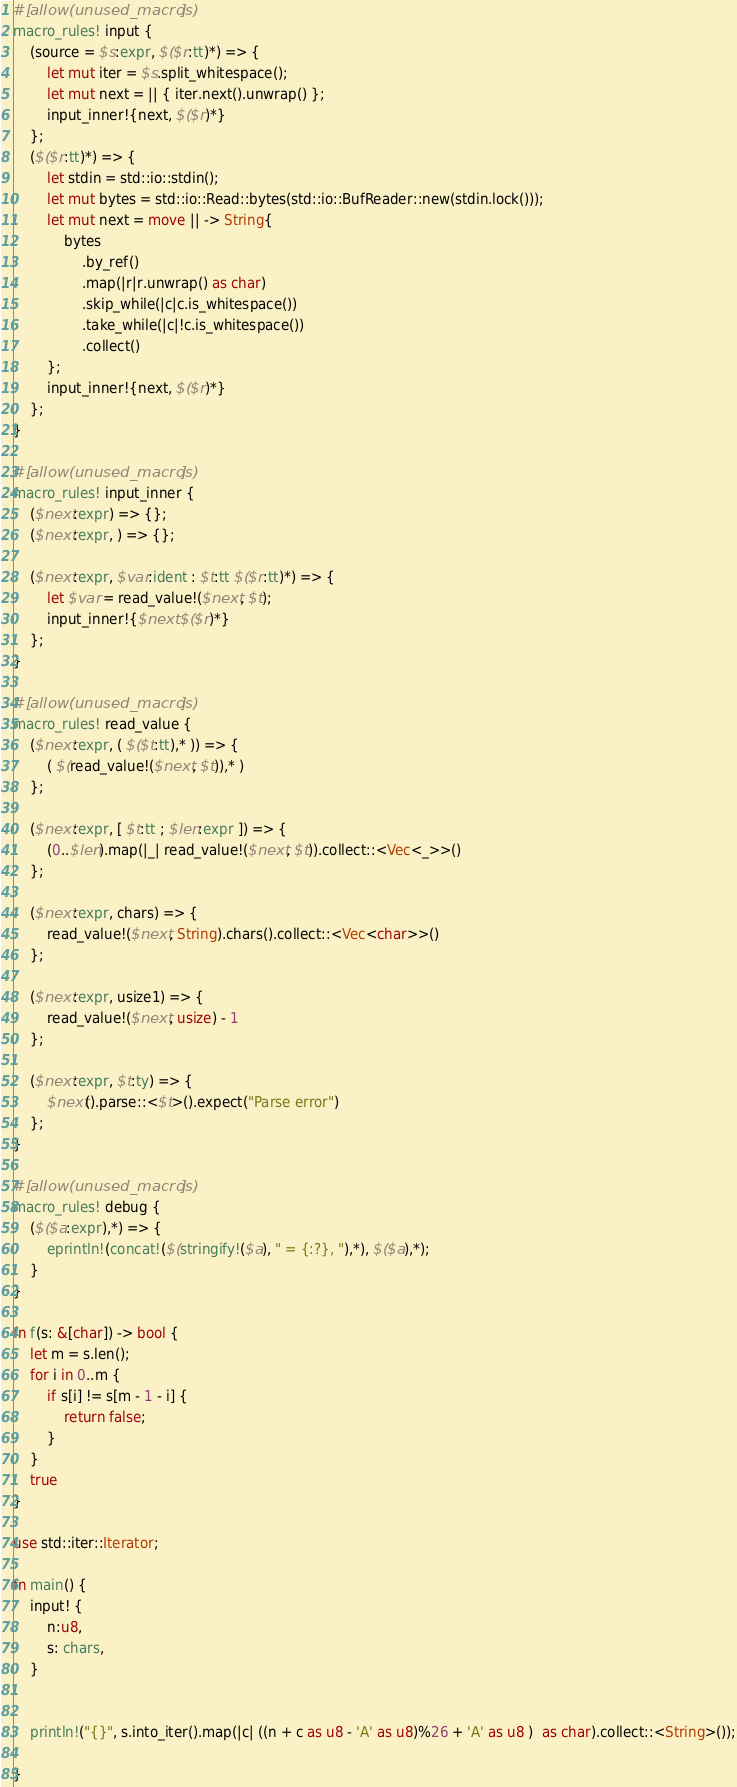<code> <loc_0><loc_0><loc_500><loc_500><_Rust_>#[allow(unused_macros)]
macro_rules! input {
    (source = $s:expr, $($r:tt)*) => {
        let mut iter = $s.split_whitespace();
        let mut next = || { iter.next().unwrap() };
        input_inner!{next, $($r)*}
    };
    ($($r:tt)*) => {
        let stdin = std::io::stdin();
        let mut bytes = std::io::Read::bytes(std::io::BufReader::new(stdin.lock()));
        let mut next = move || -> String{
            bytes
                .by_ref()
                .map(|r|r.unwrap() as char)
                .skip_while(|c|c.is_whitespace())
                .take_while(|c|!c.is_whitespace())
                .collect()
        };
        input_inner!{next, $($r)*}
    };
}

#[allow(unused_macros)]
macro_rules! input_inner {
    ($next:expr) => {};
    ($next:expr, ) => {};

    ($next:expr, $var:ident : $t:tt $($r:tt)*) => {
        let $var = read_value!($next, $t);
        input_inner!{$next $($r)*}
    };
}

#[allow(unused_macros)]
macro_rules! read_value {
    ($next:expr, ( $($t:tt),* )) => {
        ( $(read_value!($next, $t)),* )
    };

    ($next:expr, [ $t:tt ; $len:expr ]) => {
        (0..$len).map(|_| read_value!($next, $t)).collect::<Vec<_>>()
    };

    ($next:expr, chars) => {
        read_value!($next, String).chars().collect::<Vec<char>>()
    };

    ($next:expr, usize1) => {
        read_value!($next, usize) - 1
    };

    ($next:expr, $t:ty) => {
        $next().parse::<$t>().expect("Parse error")
    };
}

#[allow(unused_macros)]
macro_rules! debug {
    ($($a:expr),*) => {
        eprintln!(concat!($(stringify!($a), " = {:?}, "),*), $($a),*);
    }
}

fn f(s: &[char]) -> bool {
    let m = s.len();
    for i in 0..m {
        if s[i] != s[m - 1 - i] {
            return false;
        }
    }
    true
}

use std::iter::Iterator;

fn main() {
    input! {
        n:u8,
        s: chars,
    }


    println!("{}", s.into_iter().map(|c| ((n + c as u8 - 'A' as u8)%26 + 'A' as u8 )  as char).collect::<String>());

}
</code> 